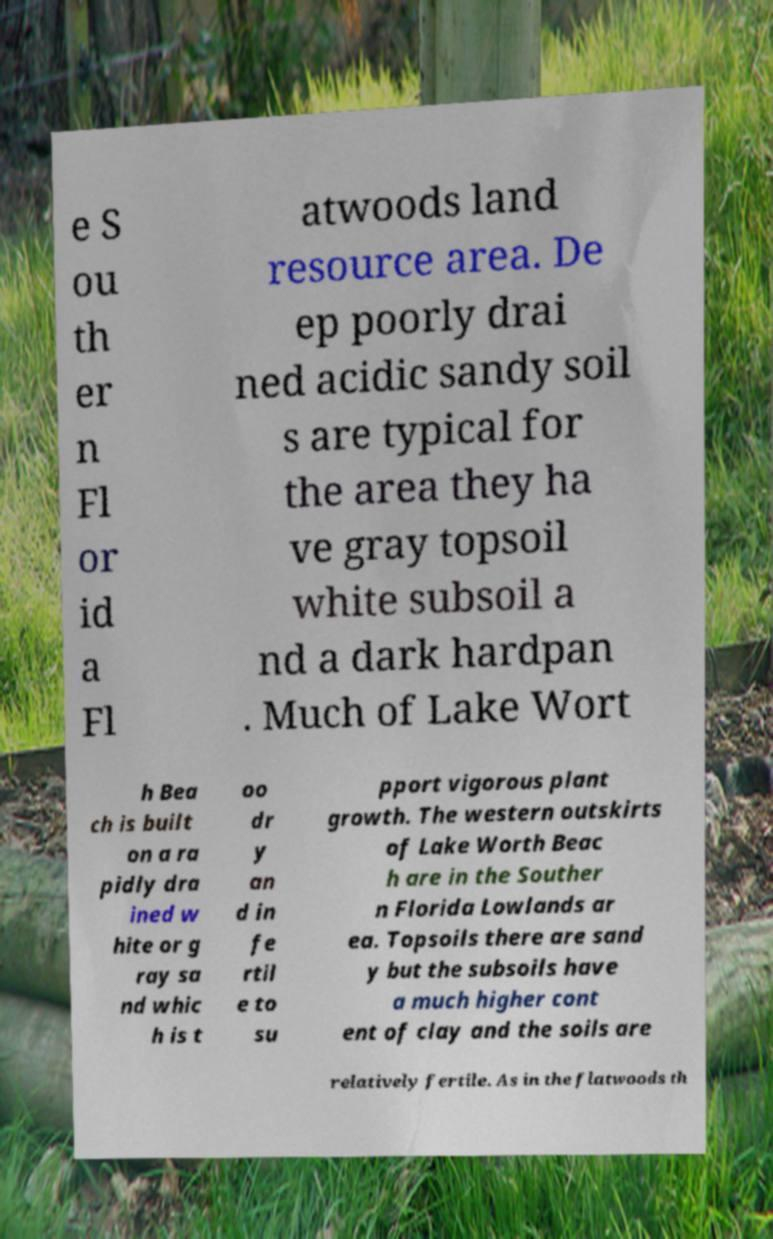Could you extract and type out the text from this image? e S ou th er n Fl or id a Fl atwoods land resource area. De ep poorly drai ned acidic sandy soil s are typical for the area they ha ve gray topsoil white subsoil a nd a dark hardpan . Much of Lake Wort h Bea ch is built on a ra pidly dra ined w hite or g ray sa nd whic h is t oo dr y an d in fe rtil e to su pport vigorous plant growth. The western outskirts of Lake Worth Beac h are in the Souther n Florida Lowlands ar ea. Topsoils there are sand y but the subsoils have a much higher cont ent of clay and the soils are relatively fertile. As in the flatwoods th 